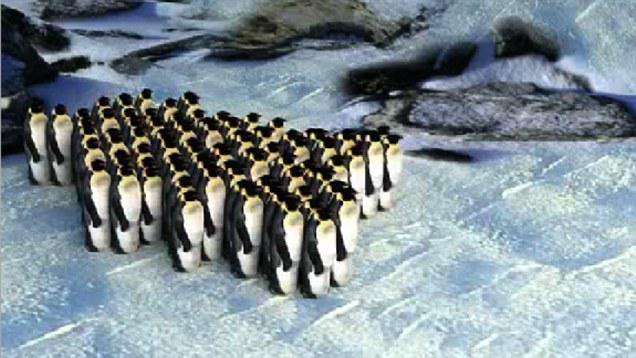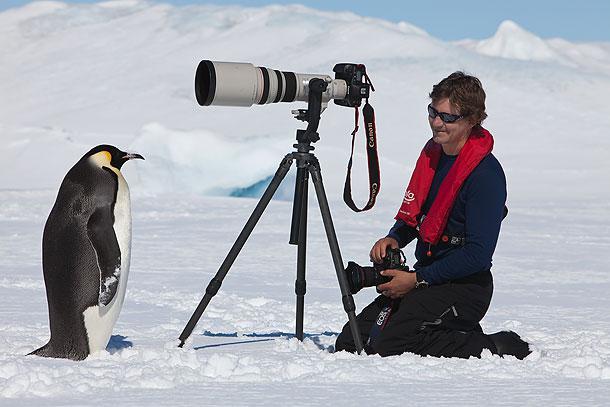The first image is the image on the left, the second image is the image on the right. Considering the images on both sides, is "One camera is attached to a tripod that's resting on the ground." valid? Answer yes or no. Yes. The first image is the image on the left, the second image is the image on the right. Examine the images to the left and right. Is the description "An image includes at least one penguin and a person behind a scope on a tripod." accurate? Answer yes or no. Yes. 